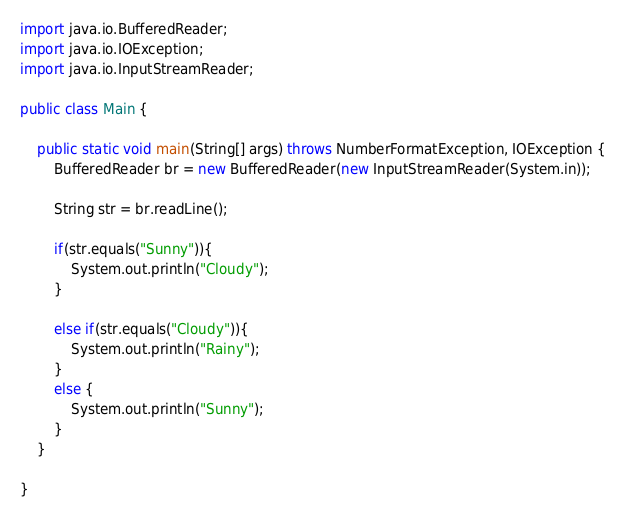Convert code to text. <code><loc_0><loc_0><loc_500><loc_500><_Java_>
import java.io.BufferedReader;
import java.io.IOException;
import java.io.InputStreamReader;

public class Main {

	public static void main(String[] args) throws NumberFormatException, IOException {
		BufferedReader br = new BufferedReader(new InputStreamReader(System.in));

		String str = br.readLine();

		if(str.equals("Sunny")){
			System.out.println("Cloudy");
		}

		else if(str.equals("Cloudy")){
			System.out.println("Rainy");
		}
		else {
			System.out.println("Sunny");
		}
	}

}
</code> 